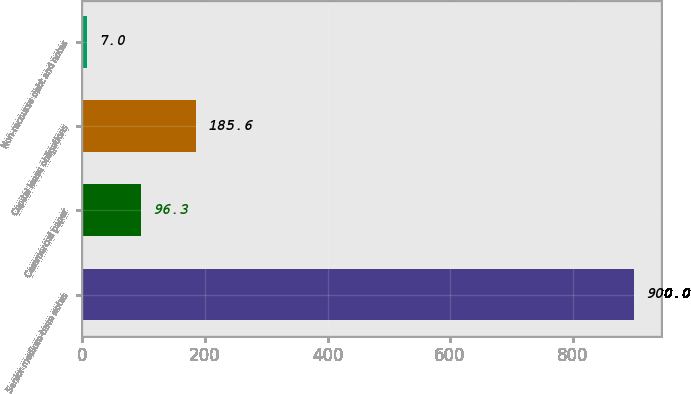Convert chart. <chart><loc_0><loc_0><loc_500><loc_500><bar_chart><fcel>Senior medium-term notes<fcel>Commercial paper<fcel>Capital lease obligations<fcel>Non-recourse debt and notes<nl><fcel>900<fcel>96.3<fcel>185.6<fcel>7<nl></chart> 